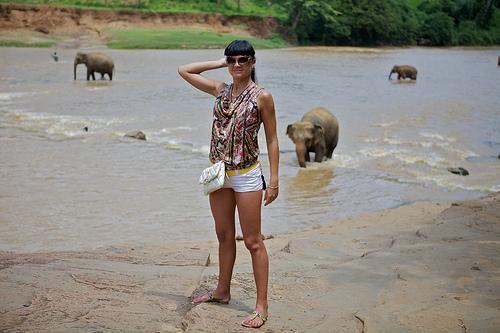How many women are in the picture?
Give a very brief answer. 1. 